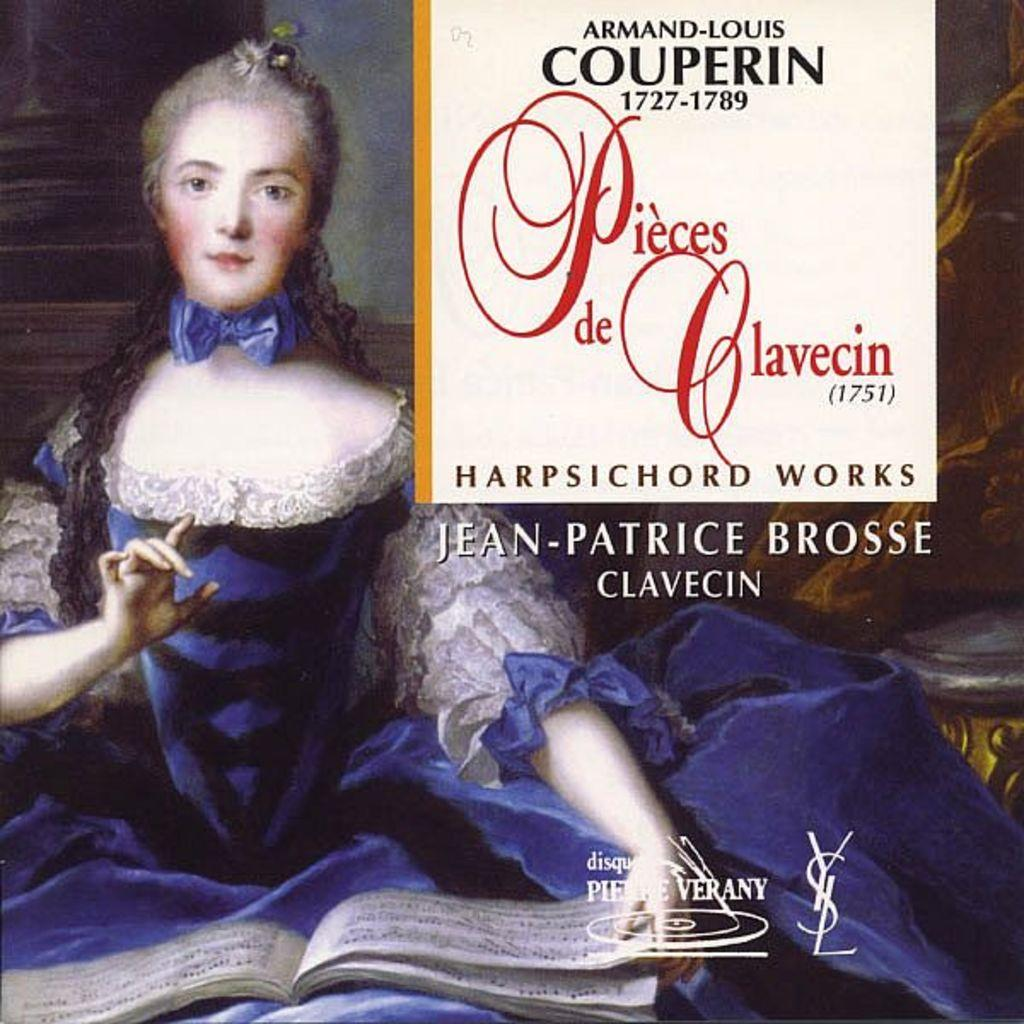<image>
Describe the image concisely. a dvd cover for Armand-Louis Couperin Harpsicord Works 